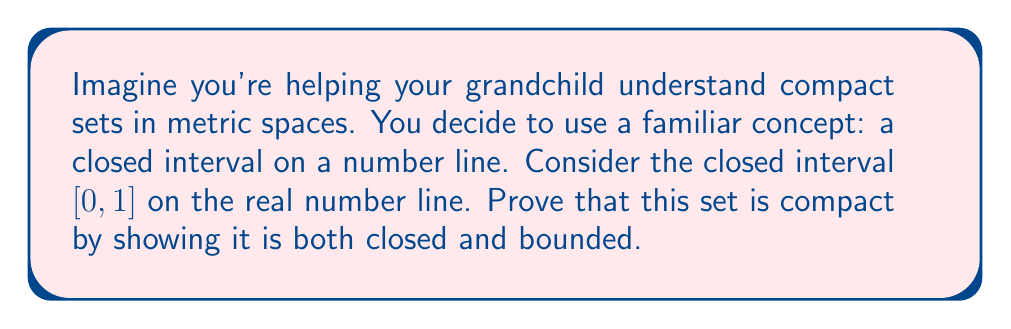Help me with this question. Let's approach this step-by-step:

1) To prove that $[0,1]$ is compact in the metric space $(\mathbb{R}, d)$ where $d$ is the standard Euclidean metric, we need to show it's both closed and bounded.

2) First, let's prove it's closed:
   - A set is closed if it contains all of its limit points.
   - Consider any convergent sequence $(x_n)$ in $[0,1]$.
   - By the definition of $[0,1]$, we know that $0 \leq x_n \leq 1$ for all $n$.
   - Let $\lim_{n \to \infty} x_n = x$.
   - By the properties of limits, we must have $0 \leq x \leq 1$.
   - Therefore, $x \in [0,1]$, so $[0,1]$ contains all its limit points and is closed.

3) Now, let's prove it's bounded:
   - A set is bounded if there exists a real number $M > 0$ such that $d(x,y) \leq M$ for all $x,y$ in the set.
   - For any $x,y \in [0,1]$, we have:
     $$d(x,y) = |x-y| \leq |1-0| = 1$$
   - Therefore, we can choose $M = 1$, and $[0,1]$ is bounded.

4) Since $[0,1]$ is both closed and bounded, by the Heine-Borel theorem, it is compact in $\mathbb{R}$.

This proof demonstrates two key properties of compact sets in metric spaces:
- They contain all their limit points (closed).
- They can be enclosed within a finite distance (bounded).
Answer: The closed interval $[0,1]$ is compact in the metric space $(\mathbb{R}, d)$ because it is both closed (contains all its limit points) and bounded (all points are within a finite distance of each other). 